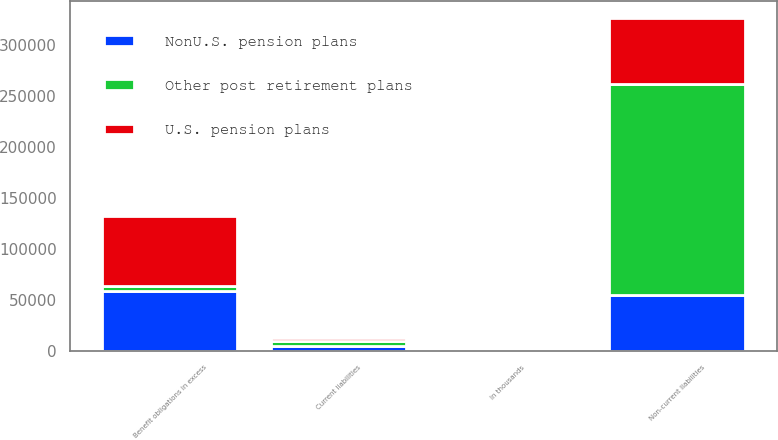<chart> <loc_0><loc_0><loc_500><loc_500><stacked_bar_chart><ecel><fcel>In thousands<fcel>Current liabilities<fcel>Non-current liabilities<fcel>Benefit obligations in excess<nl><fcel>U.S. pension plans<fcel>2012<fcel>3490<fcel>64614<fcel>68104<nl><fcel>Other post retirement plans<fcel>2012<fcel>4925<fcel>206942<fcel>4925<nl><fcel>NonU.S. pension plans<fcel>2012<fcel>4520<fcel>54777<fcel>59297<nl></chart> 